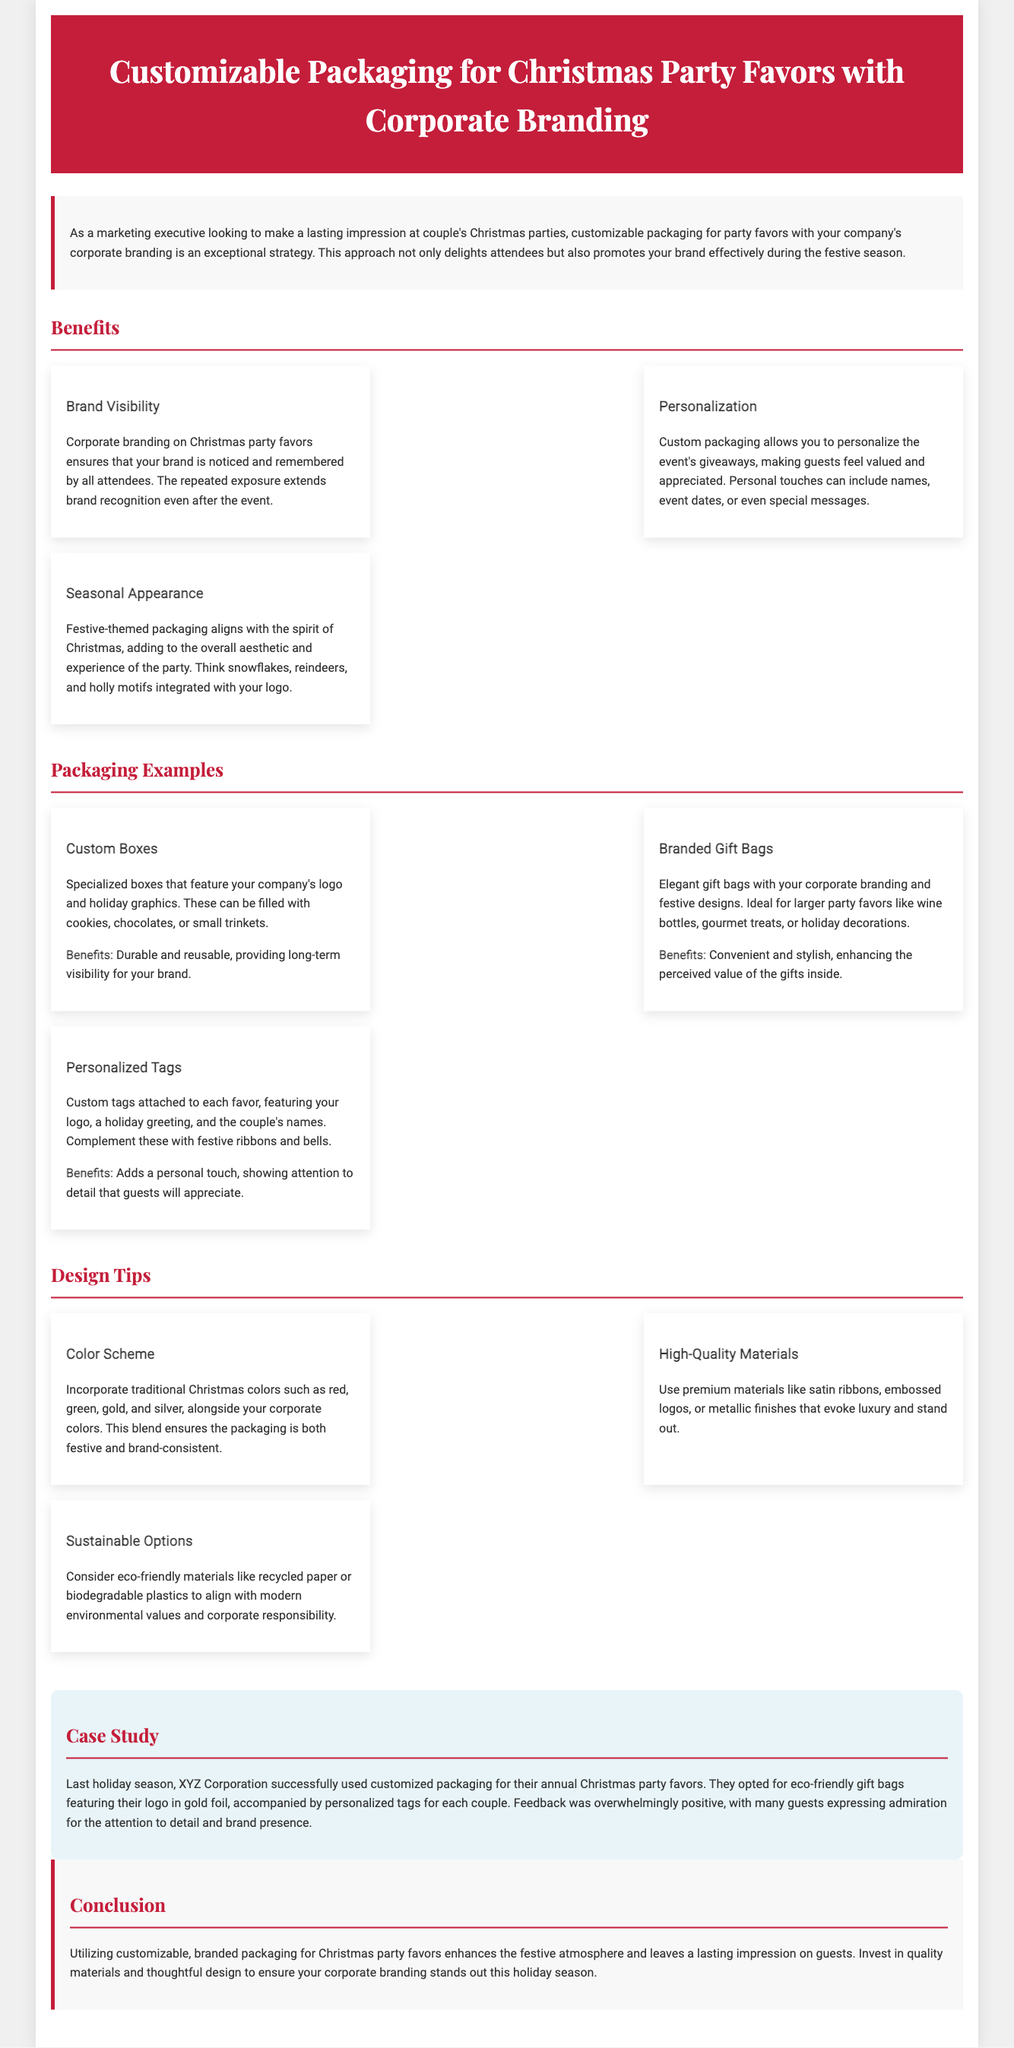what is the main focus of the document? The document discusses customizable packaging for Christmas party favors with an emphasis on corporate branding.
Answer: customizable packaging for Christmas party favors with corporate branding how many benefits of customizable packaging are mentioned? The document lists three distinct benefits of customizable packaging for Christmas party favors.
Answer: three what is one design tip provided in the document? The document includes several design tips, and one of them emphasizes using a color scheme with traditional Christmas colors.
Answer: color scheme what type of packaging is described as durable and reusable? The document mentions custom boxes that are designed to be durable and provide long-term visibility.
Answer: custom boxes what seasonal theme is suggested for the packaging design? The document recommends incorporating festive themes such as snowflakes, reindeers, and holly motifs.
Answer: festive-themed what company is mentioned in the case study? The case study in the document references a successful branding effort by XYZ Corporation during the holiday season.
Answer: XYZ Corporation name one material suggested for high-quality packaging. The document suggests using premium materials like satin ribbons for packaging.
Answer: satin ribbons how does personalized packaging affect guests according to the document? Personalization in packaging makes guests feel valued and appreciated during the event.
Answer: valued and appreciated what color is prominently featured in the document's header? The header of the document is colored deep red, specifically #C41E3A.
Answer: #C41E3A 